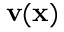<formula> <loc_0><loc_0><loc_500><loc_500>v ( x )</formula> 